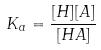<formula> <loc_0><loc_0><loc_500><loc_500>K _ { a } = \frac { [ H ] [ A ] } { [ H A ] }</formula> 